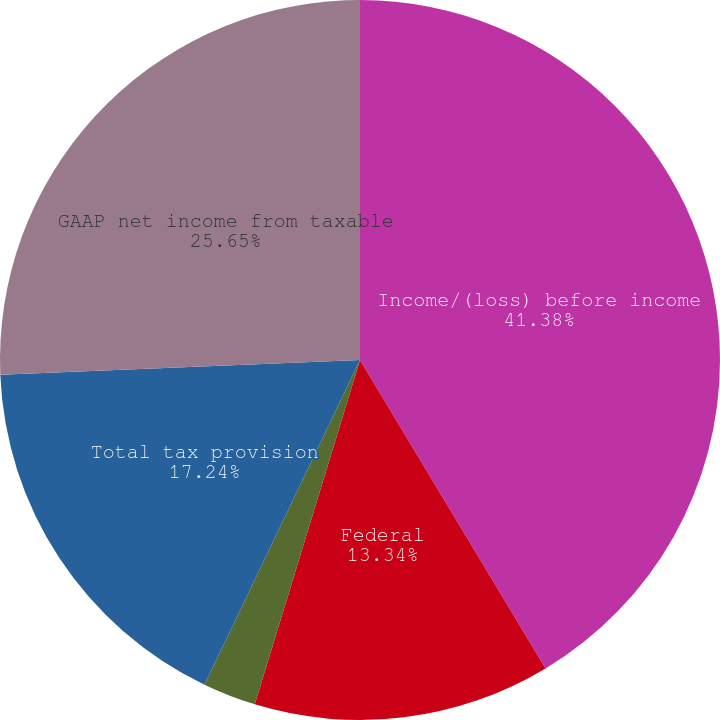Convert chart. <chart><loc_0><loc_0><loc_500><loc_500><pie_chart><fcel>Income/(loss) before income<fcel>Federal<fcel>State and local<fcel>Total tax provision<fcel>GAAP net income from taxable<nl><fcel>41.38%<fcel>13.34%<fcel>2.39%<fcel>17.24%<fcel>25.65%<nl></chart> 